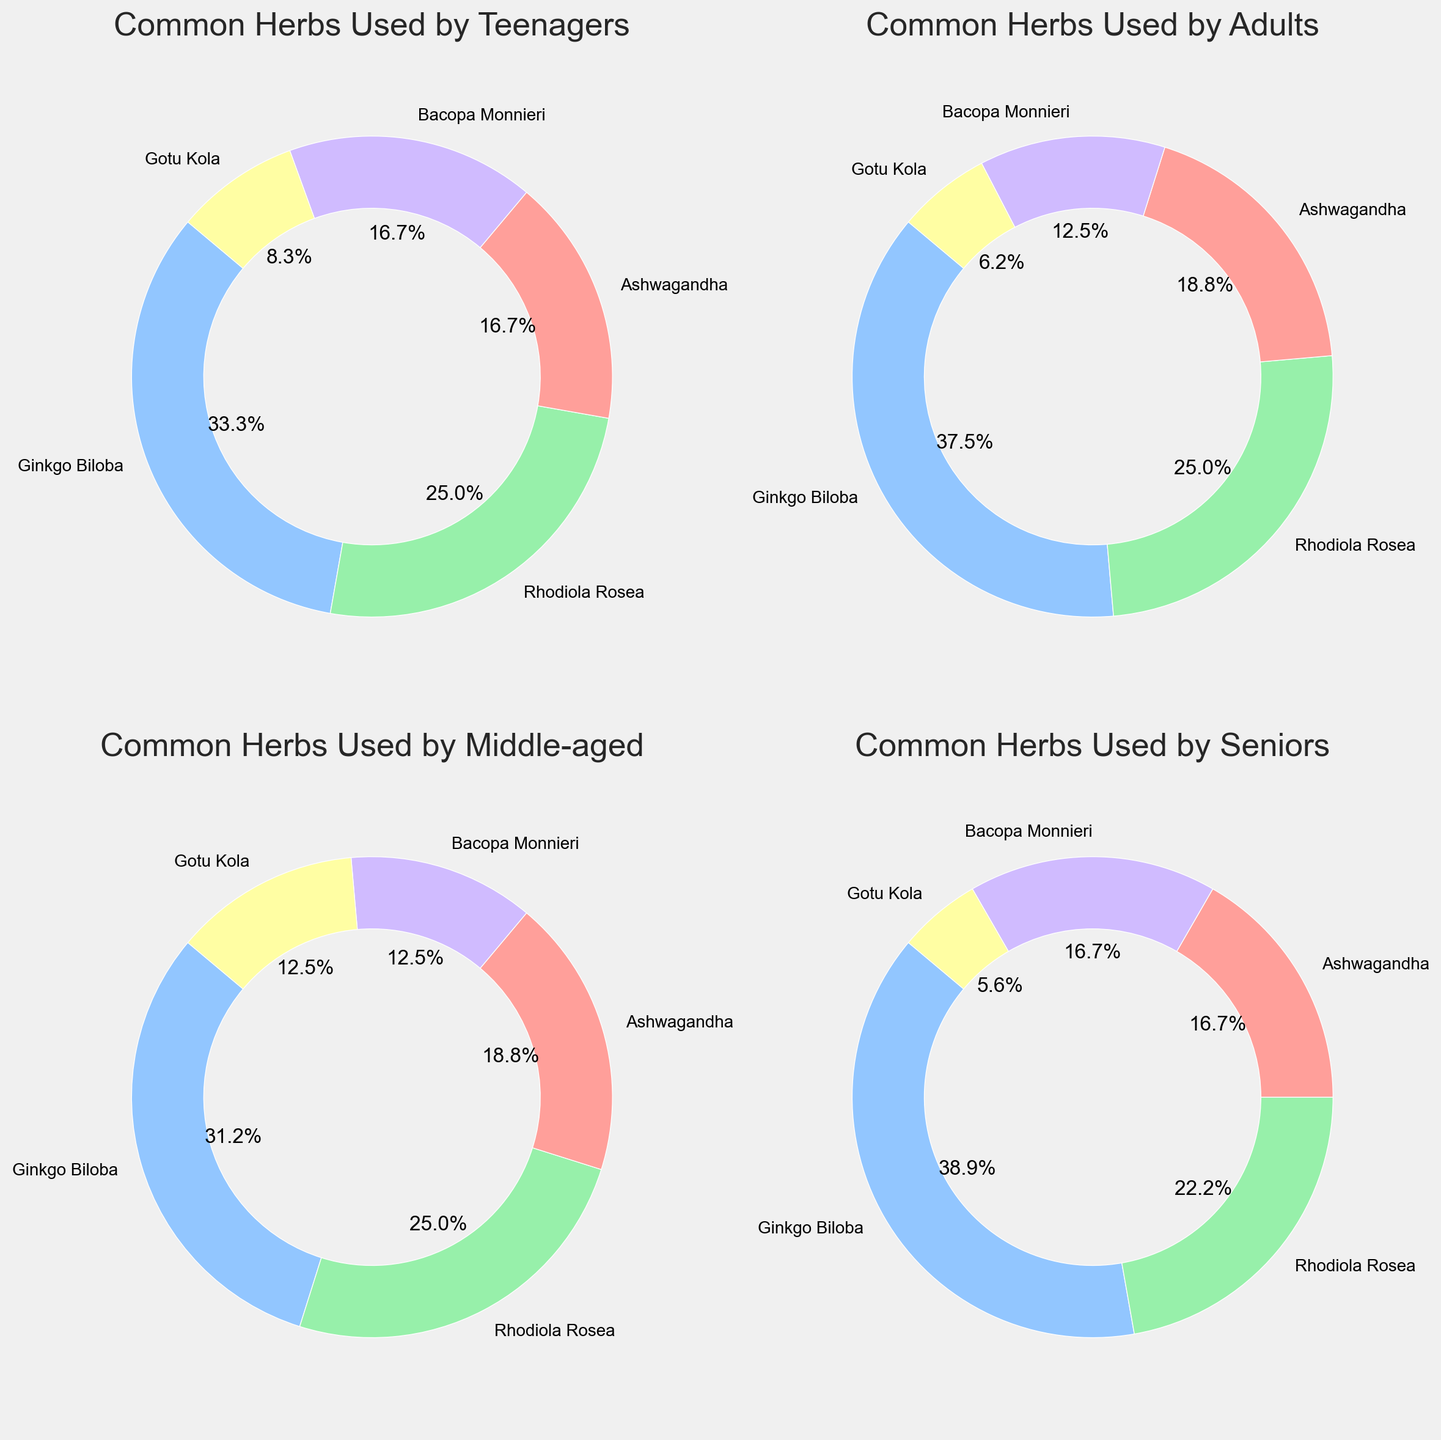What's the most commonly used herb among teenagers? To answer this, we look at the pie chart for the "Teenagers" age group. The largest wedge of the circle represents Ginkgo Biloba at 20%.
Answer: Ginkgo Biloba Which age group has the highest usage of Bacopa Monnieri? We compare the usage percentages of Bacopa Monnieri in all age groups. The highest percentage is 15% among seniors.
Answer: Seniors Is the percentage of Ginkgo Biloba usage higher among adults or middle-aged individuals? By comparing the slices, we see that adults use Ginkgo Biloba at 30%, while the middle-aged group uses it at 25%. Therefore, adults have a higher usage percentage.
Answer: Adults What is the total percentage of Ashwagandha usage across all age groups? We sum the percentages of Ashwagandha for all age groups: 10% from teenagers, 15% from adults, 15% from the middle-aged, and 15% from seniors. The total is 10 + 15 + 15 + 15 = 55%.
Answer: 55% Which herb is used equally among teenagers and middle-aged individuals, and what is the percentage? By analyzing the charts, Gotu Kola is used equally by both age groups at 5%.
Answer: Gotu Kola, 5% Between teenagers and seniors, which group uses Rhodiola Rosea more frequently? Comparing the slices, teenagers use Rhodiola Rosea at 15%, and seniors use it at 20%. Seniors have a higher usage percentage.
Answer: Seniors What is the combined percentage of Rhodiola Rosea usage in adults and seniors? Adding the percentages of Rhodiola Rosea in adults (20%) and seniors (20%), the total is 20 + 20 = 40%.
Answer: 40% Which age group has the most balanced distribution of herb usage, and why? The distribution is assessed by comparing the similarity in wedge sizes. The middle-aged group shows a relatively balanced distribution with Ginkgo Biloba (25%), Rhodiola Rosea (20%), Ashwagandha (15%), Bacopa Monnieri (10%), and Gotu Kola (10%).
Answer: Middle-aged How many age groups have Gotu Kola usage at exactly 5%? Counting the pie charts, Gotu Kola usage is 5% among teenagers, adults, and seniors, which makes it three age groups.
Answer: Three For the seniors group, what is the difference in usage percentages between Bacopa Monnieri and Gotu Kola? In the seniors group, Bacopa Monnieri usage is 15%, and Gotu Kola usage is 5%. The difference is 15 - 5 = 10%.
Answer: 10% 